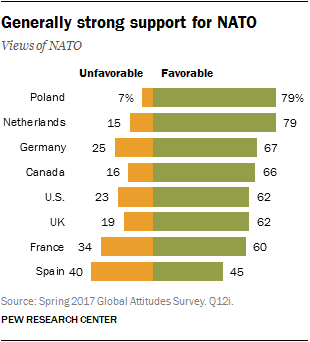Highlight a few significant elements in this photo. The total sum of the last two green bars is 105. The color of the leftmost bar is orange. 